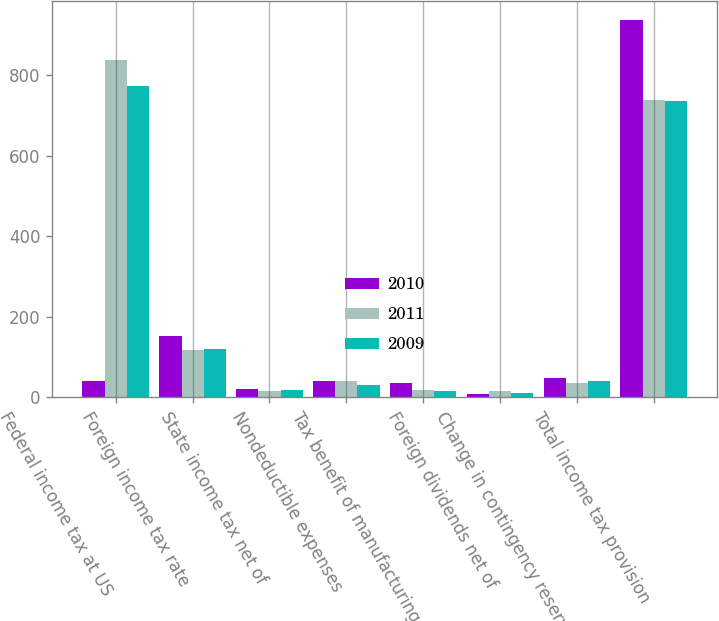Convert chart. <chart><loc_0><loc_0><loc_500><loc_500><stacked_bar_chart><ecel><fcel>Federal income tax at US<fcel>Foreign income tax rate<fcel>State income tax net of<fcel>Nondeductible expenses<fcel>Tax benefit of manufacturing<fcel>Foreign dividends net of<fcel>Change in contingency reserve<fcel>Total income tax provision<nl><fcel>2010<fcel>40<fcel>152<fcel>22<fcel>42<fcel>37<fcel>9<fcel>48<fcel>937<nl><fcel>2011<fcel>839<fcel>117<fcel>17<fcel>40<fcel>19<fcel>15<fcel>37<fcel>738<nl><fcel>2009<fcel>773<fcel>120<fcel>18<fcel>30<fcel>17<fcel>10<fcel>41<fcel>735<nl></chart> 